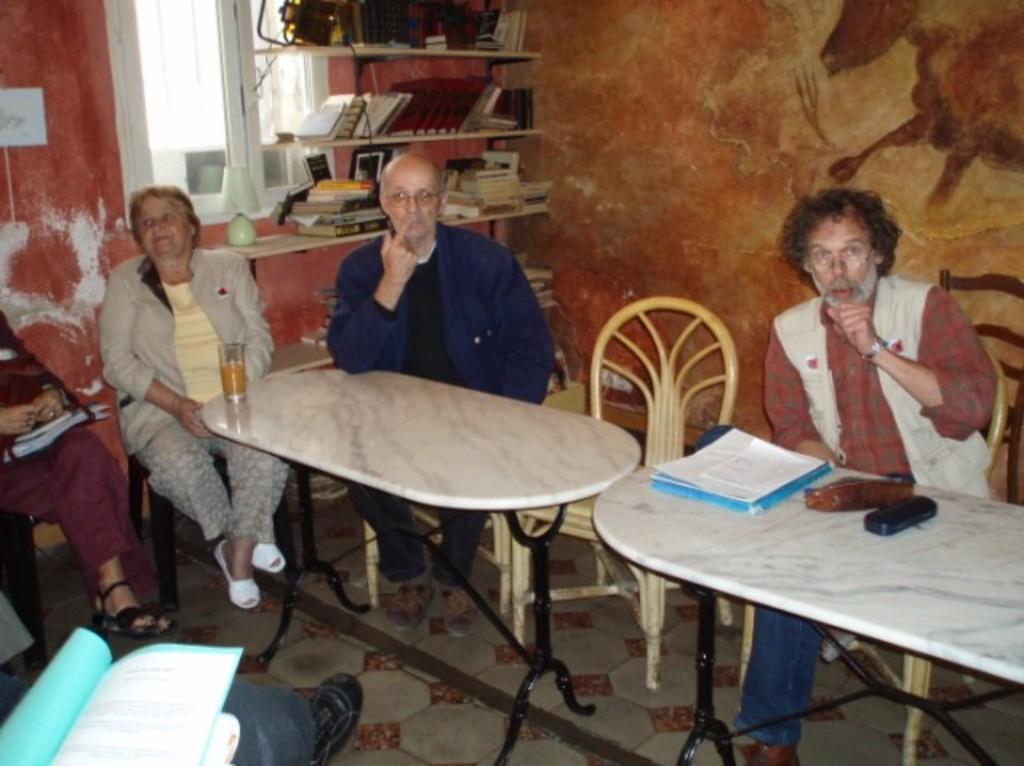Could you give a brief overview of what you see in this image? In this image there are group of peoples sitting on a chair and two center tables with a white colour top and black colour stand. On the right side of a table there is spectacle case and group of papers on the left side of the table there is one glass. In the background there shelves and a books is kept on that shelf and a white colour window. 